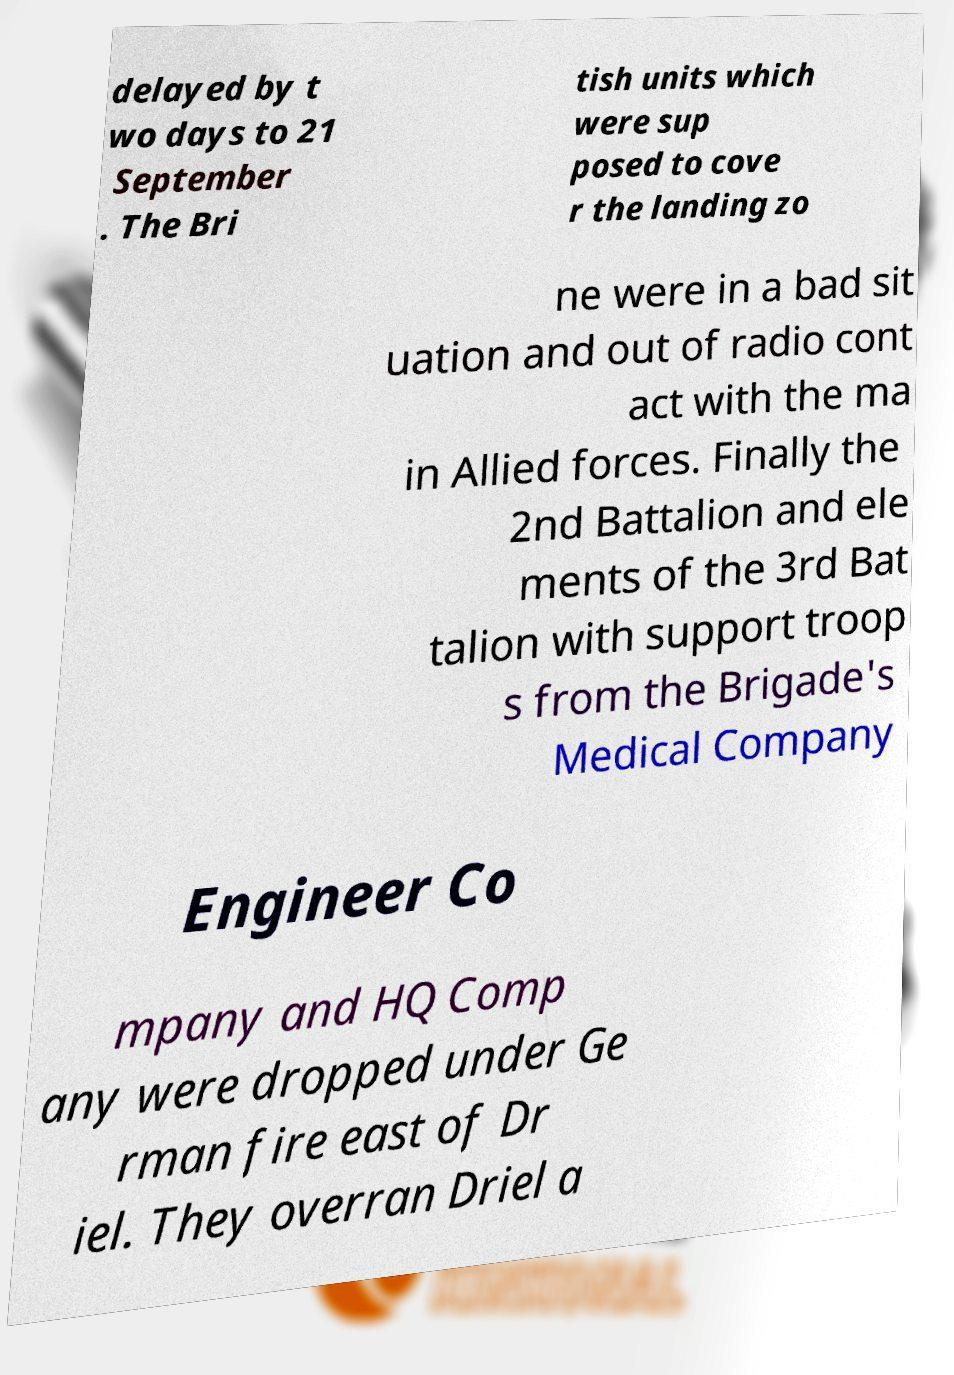I need the written content from this picture converted into text. Can you do that? delayed by t wo days to 21 September . The Bri tish units which were sup posed to cove r the landing zo ne were in a bad sit uation and out of radio cont act with the ma in Allied forces. Finally the 2nd Battalion and ele ments of the 3rd Bat talion with support troop s from the Brigade's Medical Company Engineer Co mpany and HQ Comp any were dropped under Ge rman fire east of Dr iel. They overran Driel a 